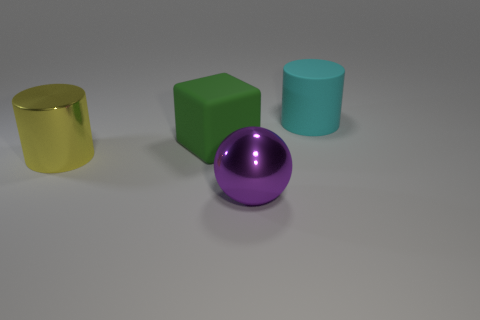If I were to group the objects by their shininess, which groups would I have? You'd have two groups; the shiny group includes the yellow cylinder and the purple sphere, while the matte group includes the green cube and the cyan cylinder. 